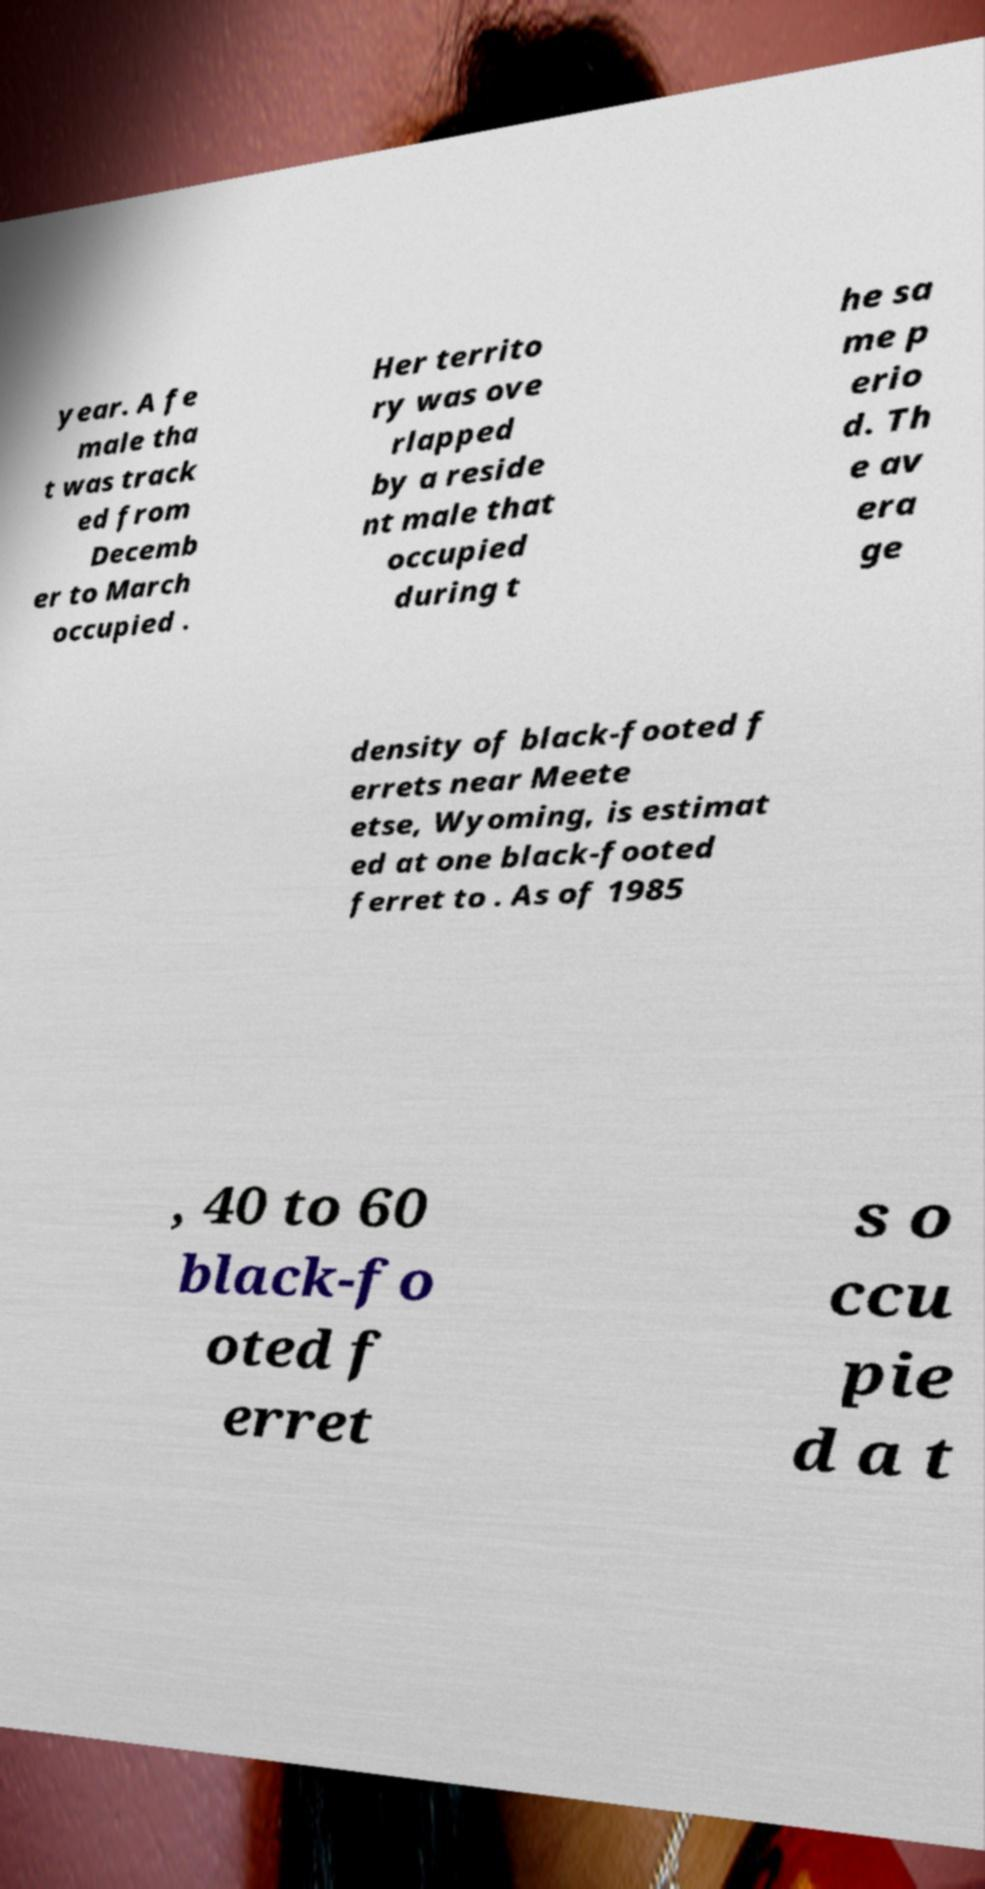For documentation purposes, I need the text within this image transcribed. Could you provide that? year. A fe male tha t was track ed from Decemb er to March occupied . Her territo ry was ove rlapped by a reside nt male that occupied during t he sa me p erio d. Th e av era ge density of black-footed f errets near Meete etse, Wyoming, is estimat ed at one black-footed ferret to . As of 1985 , 40 to 60 black-fo oted f erret s o ccu pie d a t 